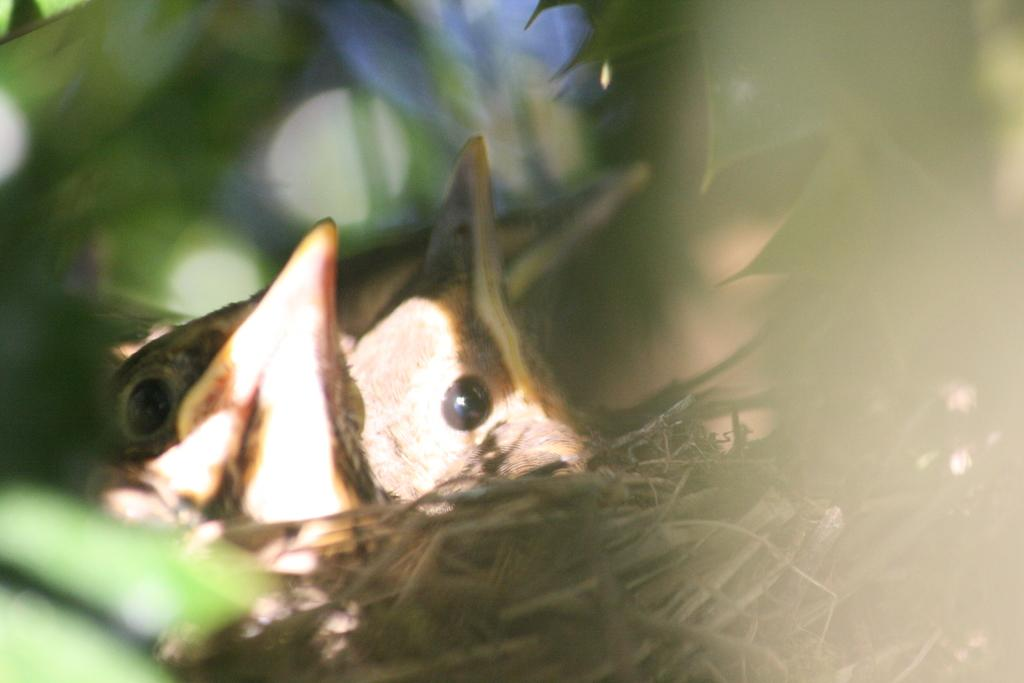What can be seen in the image that is related to birds? There is a nest in the image, and three birds are on the nest. What is surrounding the nest in the image? There are leaves around the nest. How would you describe the overall clarity of the image? The image is slightly blurry. What type of hat is the bird on the left wearing in the image? There is no hat present on any of the birds in the image. 